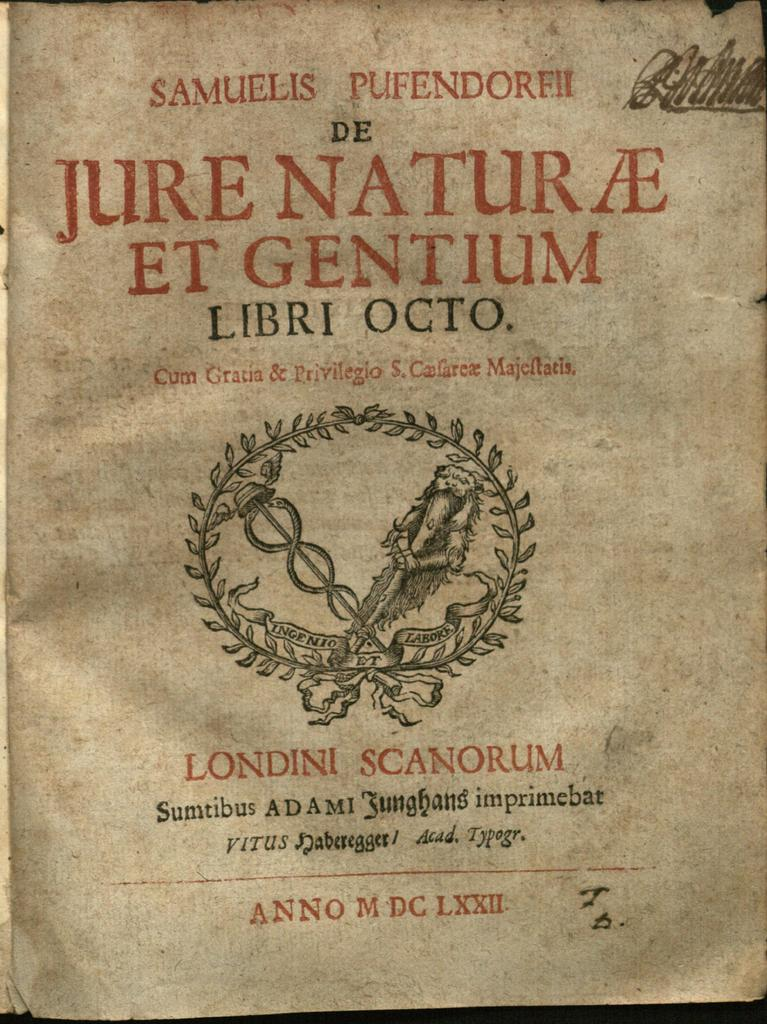Provide a one-sentence caption for the provided image. An old, yellowed page of a book written in Latin. 